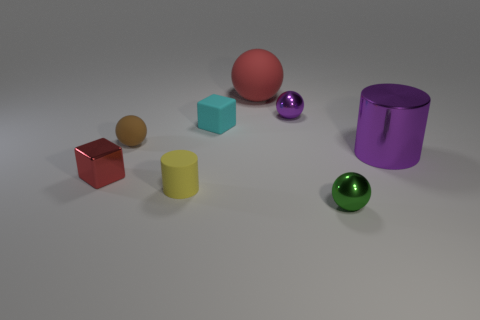How many objects in total are in the image? The image presents a total of seven distinct objects. 